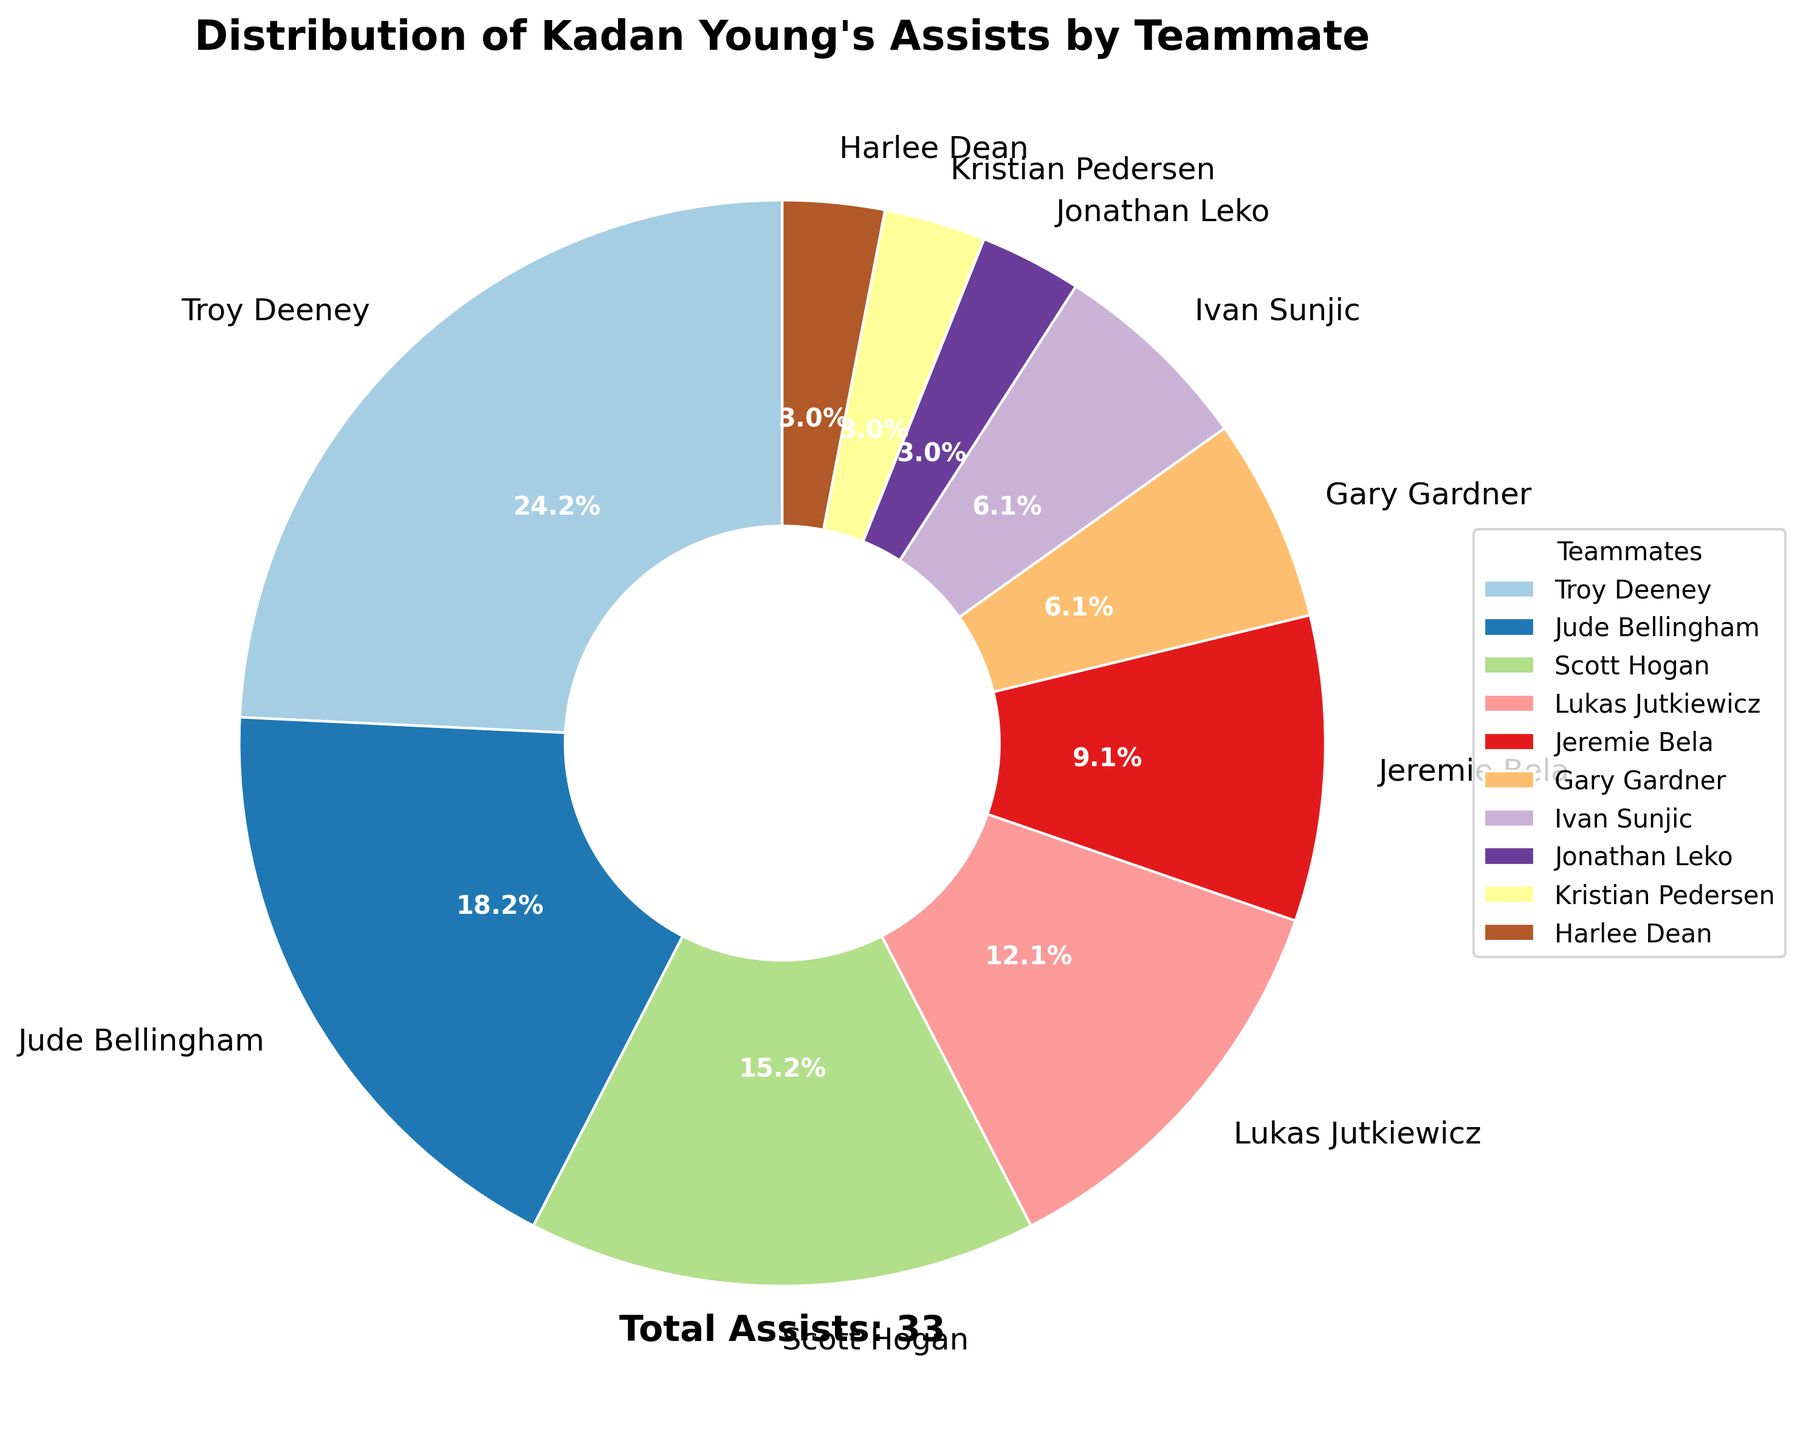Which teammate received the most assists from Kadan Young? The pie chart shows the distribution of assists among different teammates. Look for the segment with the largest percentage.
Answer: Troy Deeney How many total assists did Kadan Young provide? Check the text near the bottom of the pie chart indicating the total assists.
Answer: 33 What's the percentage of assists did Jude Bellingham receive? Find the segment labeled "Jude Bellingham" and read the percentage value shown.
Answer: 18.2% How do the assists for Scott Hogan compare to those for Lukas Jutkiewicz? Compare the number of assists for Scott Hogan (5) and Lukas Jutkiewicz (4) from the pie chart.
Answer: Scott Hogan received more assists What is the combined percentage of assists to Gary Gardner and Ivan Sunjic? Find and add the percentages for Gary Gardner and Ivan Sunjic from their respective segments in the pie chart.
Answer: 6.1% Who received exactly one assist from Kadan Young? Identify the smaller segments labeled with "1" assists. They are for Jonathan Leko, Kristian Pedersen, and Harlee Dean.
Answer: Jonathan Leko, Kristian Pedersen, and Harlee Dean What is the total number of assists to teammates other than Troy Deeney? Subtract the assists to Troy Deeney (8) from the total assists (33). 33 - 8 = 25
Answer: 25 What is the ratio of assists received by Troy Deeney to those received by Jeremie Bela? Divide the assists for Troy Deeney (8) by the assists for Jeremie Bela (3). 8/3 = 2.67
Answer: 2.67 If the assists to Scott Hogan and Lukas Jutkiewicz are combined, would that total exceed Troy Deeney's assists? Combine the assists for Scott Hogan (5) and Lukas Jutkiewicz (4), then compare to Troy Deeney's assists (8). 5 + 4 = 9, which is more than 8
Answer: Yes, it would exceed How many teammates received more than 3 assists? Count how many segments show a number greater than 3. Teammates are Troy Deeney, Jude Bellingham, Scott Hogan, and Lukas Jutkiewicz (4 in total).
Answer: 4 